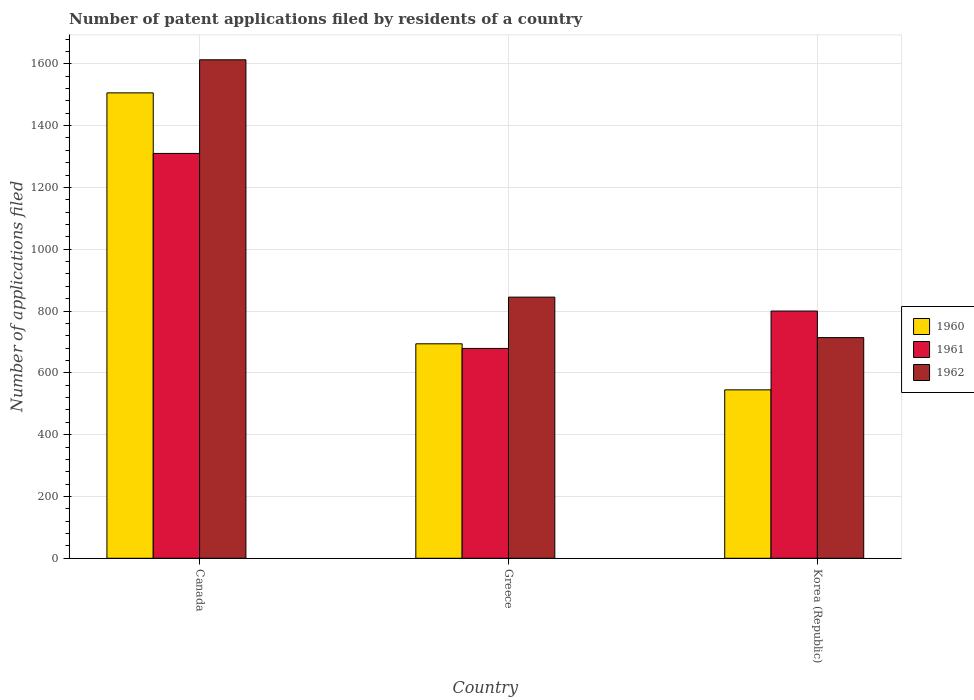Are the number of bars on each tick of the X-axis equal?
Offer a very short reply. Yes. How many bars are there on the 2nd tick from the left?
Offer a very short reply. 3. How many bars are there on the 1st tick from the right?
Your answer should be compact. 3. What is the label of the 3rd group of bars from the left?
Your response must be concise. Korea (Republic). What is the number of applications filed in 1960 in Korea (Republic)?
Make the answer very short. 545. Across all countries, what is the maximum number of applications filed in 1961?
Provide a succinct answer. 1310. Across all countries, what is the minimum number of applications filed in 1962?
Your answer should be very brief. 714. What is the total number of applications filed in 1962 in the graph?
Offer a terse response. 3172. What is the difference between the number of applications filed in 1961 in Canada and that in Korea (Republic)?
Make the answer very short. 510. What is the difference between the number of applications filed in 1962 in Korea (Republic) and the number of applications filed in 1961 in Greece?
Provide a succinct answer. 35. What is the average number of applications filed in 1960 per country?
Provide a short and direct response. 915. What is the difference between the number of applications filed of/in 1962 and number of applications filed of/in 1961 in Greece?
Provide a succinct answer. 166. In how many countries, is the number of applications filed in 1961 greater than 1040?
Your answer should be very brief. 1. What is the ratio of the number of applications filed in 1962 in Greece to that in Korea (Republic)?
Your answer should be compact. 1.18. Is the difference between the number of applications filed in 1962 in Canada and Korea (Republic) greater than the difference between the number of applications filed in 1961 in Canada and Korea (Republic)?
Your answer should be very brief. Yes. What is the difference between the highest and the second highest number of applications filed in 1962?
Ensure brevity in your answer.  -131. What is the difference between the highest and the lowest number of applications filed in 1961?
Offer a very short reply. 631. What does the 1st bar from the right in Greece represents?
Give a very brief answer. 1962. Are the values on the major ticks of Y-axis written in scientific E-notation?
Your response must be concise. No. Does the graph contain grids?
Keep it short and to the point. Yes. Where does the legend appear in the graph?
Offer a terse response. Center right. What is the title of the graph?
Keep it short and to the point. Number of patent applications filed by residents of a country. Does "1975" appear as one of the legend labels in the graph?
Ensure brevity in your answer.  No. What is the label or title of the Y-axis?
Give a very brief answer. Number of applications filed. What is the Number of applications filed of 1960 in Canada?
Give a very brief answer. 1506. What is the Number of applications filed in 1961 in Canada?
Give a very brief answer. 1310. What is the Number of applications filed in 1962 in Canada?
Provide a succinct answer. 1613. What is the Number of applications filed in 1960 in Greece?
Provide a short and direct response. 694. What is the Number of applications filed in 1961 in Greece?
Your answer should be compact. 679. What is the Number of applications filed in 1962 in Greece?
Offer a terse response. 845. What is the Number of applications filed in 1960 in Korea (Republic)?
Your answer should be compact. 545. What is the Number of applications filed in 1961 in Korea (Republic)?
Keep it short and to the point. 800. What is the Number of applications filed of 1962 in Korea (Republic)?
Make the answer very short. 714. Across all countries, what is the maximum Number of applications filed of 1960?
Make the answer very short. 1506. Across all countries, what is the maximum Number of applications filed in 1961?
Your answer should be compact. 1310. Across all countries, what is the maximum Number of applications filed in 1962?
Offer a very short reply. 1613. Across all countries, what is the minimum Number of applications filed in 1960?
Offer a very short reply. 545. Across all countries, what is the minimum Number of applications filed in 1961?
Offer a very short reply. 679. Across all countries, what is the minimum Number of applications filed of 1962?
Provide a succinct answer. 714. What is the total Number of applications filed in 1960 in the graph?
Make the answer very short. 2745. What is the total Number of applications filed of 1961 in the graph?
Provide a short and direct response. 2789. What is the total Number of applications filed in 1962 in the graph?
Keep it short and to the point. 3172. What is the difference between the Number of applications filed in 1960 in Canada and that in Greece?
Give a very brief answer. 812. What is the difference between the Number of applications filed of 1961 in Canada and that in Greece?
Your answer should be compact. 631. What is the difference between the Number of applications filed in 1962 in Canada and that in Greece?
Make the answer very short. 768. What is the difference between the Number of applications filed of 1960 in Canada and that in Korea (Republic)?
Make the answer very short. 961. What is the difference between the Number of applications filed in 1961 in Canada and that in Korea (Republic)?
Your response must be concise. 510. What is the difference between the Number of applications filed in 1962 in Canada and that in Korea (Republic)?
Offer a terse response. 899. What is the difference between the Number of applications filed in 1960 in Greece and that in Korea (Republic)?
Your response must be concise. 149. What is the difference between the Number of applications filed of 1961 in Greece and that in Korea (Republic)?
Keep it short and to the point. -121. What is the difference between the Number of applications filed of 1962 in Greece and that in Korea (Republic)?
Your answer should be very brief. 131. What is the difference between the Number of applications filed in 1960 in Canada and the Number of applications filed in 1961 in Greece?
Your answer should be very brief. 827. What is the difference between the Number of applications filed of 1960 in Canada and the Number of applications filed of 1962 in Greece?
Your answer should be very brief. 661. What is the difference between the Number of applications filed of 1961 in Canada and the Number of applications filed of 1962 in Greece?
Keep it short and to the point. 465. What is the difference between the Number of applications filed of 1960 in Canada and the Number of applications filed of 1961 in Korea (Republic)?
Offer a terse response. 706. What is the difference between the Number of applications filed of 1960 in Canada and the Number of applications filed of 1962 in Korea (Republic)?
Offer a terse response. 792. What is the difference between the Number of applications filed in 1961 in Canada and the Number of applications filed in 1962 in Korea (Republic)?
Provide a succinct answer. 596. What is the difference between the Number of applications filed of 1960 in Greece and the Number of applications filed of 1961 in Korea (Republic)?
Provide a short and direct response. -106. What is the difference between the Number of applications filed of 1961 in Greece and the Number of applications filed of 1962 in Korea (Republic)?
Give a very brief answer. -35. What is the average Number of applications filed of 1960 per country?
Provide a short and direct response. 915. What is the average Number of applications filed in 1961 per country?
Your answer should be very brief. 929.67. What is the average Number of applications filed in 1962 per country?
Your response must be concise. 1057.33. What is the difference between the Number of applications filed of 1960 and Number of applications filed of 1961 in Canada?
Provide a succinct answer. 196. What is the difference between the Number of applications filed in 1960 and Number of applications filed in 1962 in Canada?
Provide a short and direct response. -107. What is the difference between the Number of applications filed of 1961 and Number of applications filed of 1962 in Canada?
Your answer should be very brief. -303. What is the difference between the Number of applications filed in 1960 and Number of applications filed in 1962 in Greece?
Ensure brevity in your answer.  -151. What is the difference between the Number of applications filed in 1961 and Number of applications filed in 1962 in Greece?
Ensure brevity in your answer.  -166. What is the difference between the Number of applications filed of 1960 and Number of applications filed of 1961 in Korea (Republic)?
Ensure brevity in your answer.  -255. What is the difference between the Number of applications filed of 1960 and Number of applications filed of 1962 in Korea (Republic)?
Offer a very short reply. -169. What is the ratio of the Number of applications filed of 1960 in Canada to that in Greece?
Your response must be concise. 2.17. What is the ratio of the Number of applications filed of 1961 in Canada to that in Greece?
Provide a succinct answer. 1.93. What is the ratio of the Number of applications filed in 1962 in Canada to that in Greece?
Your response must be concise. 1.91. What is the ratio of the Number of applications filed of 1960 in Canada to that in Korea (Republic)?
Offer a terse response. 2.76. What is the ratio of the Number of applications filed of 1961 in Canada to that in Korea (Republic)?
Keep it short and to the point. 1.64. What is the ratio of the Number of applications filed in 1962 in Canada to that in Korea (Republic)?
Give a very brief answer. 2.26. What is the ratio of the Number of applications filed of 1960 in Greece to that in Korea (Republic)?
Ensure brevity in your answer.  1.27. What is the ratio of the Number of applications filed in 1961 in Greece to that in Korea (Republic)?
Your answer should be very brief. 0.85. What is the ratio of the Number of applications filed of 1962 in Greece to that in Korea (Republic)?
Make the answer very short. 1.18. What is the difference between the highest and the second highest Number of applications filed in 1960?
Ensure brevity in your answer.  812. What is the difference between the highest and the second highest Number of applications filed in 1961?
Your response must be concise. 510. What is the difference between the highest and the second highest Number of applications filed in 1962?
Your response must be concise. 768. What is the difference between the highest and the lowest Number of applications filed of 1960?
Give a very brief answer. 961. What is the difference between the highest and the lowest Number of applications filed in 1961?
Your answer should be very brief. 631. What is the difference between the highest and the lowest Number of applications filed in 1962?
Provide a succinct answer. 899. 